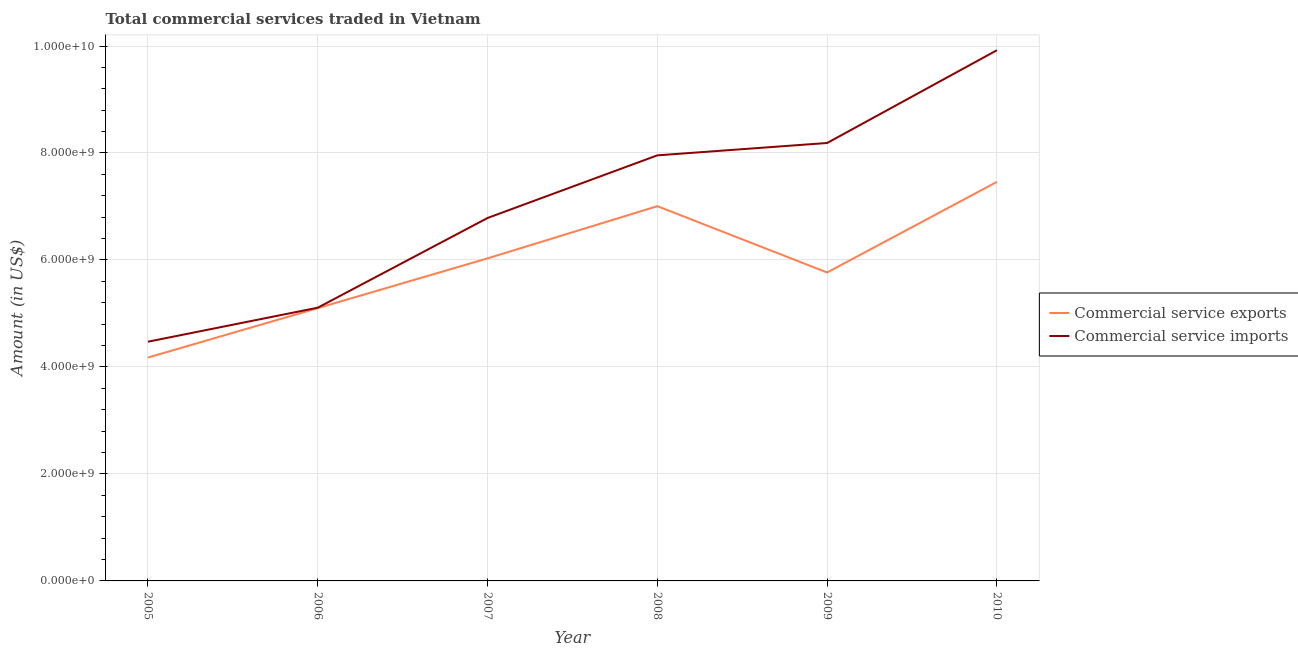How many different coloured lines are there?
Ensure brevity in your answer.  2. What is the amount of commercial service exports in 2009?
Give a very brief answer. 5.77e+09. Across all years, what is the maximum amount of commercial service imports?
Keep it short and to the point. 9.92e+09. Across all years, what is the minimum amount of commercial service exports?
Offer a very short reply. 4.18e+09. What is the total amount of commercial service imports in the graph?
Offer a very short reply. 4.24e+1. What is the difference between the amount of commercial service imports in 2008 and that in 2010?
Your response must be concise. -1.96e+09. What is the difference between the amount of commercial service imports in 2010 and the amount of commercial service exports in 2009?
Ensure brevity in your answer.  4.16e+09. What is the average amount of commercial service imports per year?
Your response must be concise. 7.07e+09. In the year 2009, what is the difference between the amount of commercial service imports and amount of commercial service exports?
Your response must be concise. 2.42e+09. In how many years, is the amount of commercial service exports greater than 8000000000 US$?
Your response must be concise. 0. What is the ratio of the amount of commercial service imports in 2005 to that in 2007?
Your answer should be compact. 0.66. What is the difference between the highest and the second highest amount of commercial service imports?
Keep it short and to the point. 1.73e+09. What is the difference between the highest and the lowest amount of commercial service imports?
Offer a terse response. 5.45e+09. In how many years, is the amount of commercial service imports greater than the average amount of commercial service imports taken over all years?
Your response must be concise. 3. Does the amount of commercial service exports monotonically increase over the years?
Ensure brevity in your answer.  No. How many years are there in the graph?
Your response must be concise. 6. Does the graph contain any zero values?
Your response must be concise. No. Where does the legend appear in the graph?
Provide a short and direct response. Center right. How many legend labels are there?
Give a very brief answer. 2. How are the legend labels stacked?
Offer a very short reply. Vertical. What is the title of the graph?
Offer a very short reply. Total commercial services traded in Vietnam. What is the label or title of the X-axis?
Make the answer very short. Year. What is the Amount (in US$) in Commercial service exports in 2005?
Keep it short and to the point. 4.18e+09. What is the Amount (in US$) in Commercial service imports in 2005?
Offer a very short reply. 4.47e+09. What is the Amount (in US$) of Commercial service exports in 2006?
Offer a very short reply. 5.10e+09. What is the Amount (in US$) in Commercial service imports in 2006?
Make the answer very short. 5.11e+09. What is the Amount (in US$) of Commercial service exports in 2007?
Ensure brevity in your answer.  6.03e+09. What is the Amount (in US$) in Commercial service imports in 2007?
Offer a terse response. 6.78e+09. What is the Amount (in US$) in Commercial service exports in 2008?
Offer a very short reply. 7.01e+09. What is the Amount (in US$) of Commercial service imports in 2008?
Your response must be concise. 7.96e+09. What is the Amount (in US$) of Commercial service exports in 2009?
Provide a short and direct response. 5.77e+09. What is the Amount (in US$) in Commercial service imports in 2009?
Your response must be concise. 8.19e+09. What is the Amount (in US$) in Commercial service exports in 2010?
Your response must be concise. 7.46e+09. What is the Amount (in US$) in Commercial service imports in 2010?
Offer a very short reply. 9.92e+09. Across all years, what is the maximum Amount (in US$) of Commercial service exports?
Offer a very short reply. 7.46e+09. Across all years, what is the maximum Amount (in US$) in Commercial service imports?
Provide a succinct answer. 9.92e+09. Across all years, what is the minimum Amount (in US$) in Commercial service exports?
Offer a terse response. 4.18e+09. Across all years, what is the minimum Amount (in US$) of Commercial service imports?
Provide a short and direct response. 4.47e+09. What is the total Amount (in US$) in Commercial service exports in the graph?
Make the answer very short. 3.55e+1. What is the total Amount (in US$) of Commercial service imports in the graph?
Offer a very short reply. 4.24e+1. What is the difference between the Amount (in US$) in Commercial service exports in 2005 and that in 2006?
Keep it short and to the point. -9.24e+08. What is the difference between the Amount (in US$) of Commercial service imports in 2005 and that in 2006?
Provide a short and direct response. -6.36e+08. What is the difference between the Amount (in US$) in Commercial service exports in 2005 and that in 2007?
Your answer should be very brief. -1.85e+09. What is the difference between the Amount (in US$) of Commercial service imports in 2005 and that in 2007?
Offer a terse response. -2.31e+09. What is the difference between the Amount (in US$) in Commercial service exports in 2005 and that in 2008?
Offer a terse response. -2.83e+09. What is the difference between the Amount (in US$) of Commercial service imports in 2005 and that in 2008?
Offer a terse response. -3.48e+09. What is the difference between the Amount (in US$) in Commercial service exports in 2005 and that in 2009?
Provide a short and direct response. -1.59e+09. What is the difference between the Amount (in US$) in Commercial service imports in 2005 and that in 2009?
Offer a very short reply. -3.72e+09. What is the difference between the Amount (in US$) of Commercial service exports in 2005 and that in 2010?
Keep it short and to the point. -3.28e+09. What is the difference between the Amount (in US$) in Commercial service imports in 2005 and that in 2010?
Provide a succinct answer. -5.45e+09. What is the difference between the Amount (in US$) in Commercial service exports in 2006 and that in 2007?
Make the answer very short. -9.30e+08. What is the difference between the Amount (in US$) of Commercial service imports in 2006 and that in 2007?
Offer a very short reply. -1.68e+09. What is the difference between the Amount (in US$) in Commercial service exports in 2006 and that in 2008?
Make the answer very short. -1.91e+09. What is the difference between the Amount (in US$) in Commercial service imports in 2006 and that in 2008?
Keep it short and to the point. -2.85e+09. What is the difference between the Amount (in US$) in Commercial service exports in 2006 and that in 2009?
Provide a short and direct response. -6.66e+08. What is the difference between the Amount (in US$) in Commercial service imports in 2006 and that in 2009?
Your answer should be compact. -3.08e+09. What is the difference between the Amount (in US$) in Commercial service exports in 2006 and that in 2010?
Ensure brevity in your answer.  -2.36e+09. What is the difference between the Amount (in US$) in Commercial service imports in 2006 and that in 2010?
Your answer should be very brief. -4.81e+09. What is the difference between the Amount (in US$) in Commercial service exports in 2007 and that in 2008?
Give a very brief answer. -9.76e+08. What is the difference between the Amount (in US$) of Commercial service imports in 2007 and that in 2008?
Your answer should be compact. -1.17e+09. What is the difference between the Amount (in US$) of Commercial service exports in 2007 and that in 2009?
Your answer should be compact. 2.64e+08. What is the difference between the Amount (in US$) in Commercial service imports in 2007 and that in 2009?
Provide a succinct answer. -1.40e+09. What is the difference between the Amount (in US$) of Commercial service exports in 2007 and that in 2010?
Give a very brief answer. -1.43e+09. What is the difference between the Amount (in US$) of Commercial service imports in 2007 and that in 2010?
Provide a succinct answer. -3.14e+09. What is the difference between the Amount (in US$) of Commercial service exports in 2008 and that in 2009?
Offer a very short reply. 1.24e+09. What is the difference between the Amount (in US$) of Commercial service imports in 2008 and that in 2009?
Provide a short and direct response. -2.31e+08. What is the difference between the Amount (in US$) in Commercial service exports in 2008 and that in 2010?
Offer a terse response. -4.54e+08. What is the difference between the Amount (in US$) in Commercial service imports in 2008 and that in 2010?
Your answer should be very brief. -1.96e+09. What is the difference between the Amount (in US$) of Commercial service exports in 2009 and that in 2010?
Offer a very short reply. -1.69e+09. What is the difference between the Amount (in US$) in Commercial service imports in 2009 and that in 2010?
Make the answer very short. -1.73e+09. What is the difference between the Amount (in US$) of Commercial service exports in 2005 and the Amount (in US$) of Commercial service imports in 2006?
Give a very brief answer. -9.32e+08. What is the difference between the Amount (in US$) of Commercial service exports in 2005 and the Amount (in US$) of Commercial service imports in 2007?
Provide a short and direct response. -2.61e+09. What is the difference between the Amount (in US$) in Commercial service exports in 2005 and the Amount (in US$) in Commercial service imports in 2008?
Offer a very short reply. -3.78e+09. What is the difference between the Amount (in US$) of Commercial service exports in 2005 and the Amount (in US$) of Commercial service imports in 2009?
Your answer should be compact. -4.01e+09. What is the difference between the Amount (in US$) in Commercial service exports in 2005 and the Amount (in US$) in Commercial service imports in 2010?
Provide a succinct answer. -5.74e+09. What is the difference between the Amount (in US$) of Commercial service exports in 2006 and the Amount (in US$) of Commercial service imports in 2007?
Provide a short and direct response. -1.68e+09. What is the difference between the Amount (in US$) of Commercial service exports in 2006 and the Amount (in US$) of Commercial service imports in 2008?
Provide a short and direct response. -2.86e+09. What is the difference between the Amount (in US$) in Commercial service exports in 2006 and the Amount (in US$) in Commercial service imports in 2009?
Your answer should be very brief. -3.09e+09. What is the difference between the Amount (in US$) in Commercial service exports in 2006 and the Amount (in US$) in Commercial service imports in 2010?
Provide a succinct answer. -4.82e+09. What is the difference between the Amount (in US$) in Commercial service exports in 2007 and the Amount (in US$) in Commercial service imports in 2008?
Offer a terse response. -1.93e+09. What is the difference between the Amount (in US$) of Commercial service exports in 2007 and the Amount (in US$) of Commercial service imports in 2009?
Your answer should be very brief. -2.16e+09. What is the difference between the Amount (in US$) of Commercial service exports in 2007 and the Amount (in US$) of Commercial service imports in 2010?
Ensure brevity in your answer.  -3.89e+09. What is the difference between the Amount (in US$) in Commercial service exports in 2008 and the Amount (in US$) in Commercial service imports in 2009?
Ensure brevity in your answer.  -1.18e+09. What is the difference between the Amount (in US$) of Commercial service exports in 2008 and the Amount (in US$) of Commercial service imports in 2010?
Your answer should be compact. -2.92e+09. What is the difference between the Amount (in US$) of Commercial service exports in 2009 and the Amount (in US$) of Commercial service imports in 2010?
Keep it short and to the point. -4.16e+09. What is the average Amount (in US$) of Commercial service exports per year?
Your response must be concise. 5.92e+09. What is the average Amount (in US$) in Commercial service imports per year?
Give a very brief answer. 7.07e+09. In the year 2005, what is the difference between the Amount (in US$) in Commercial service exports and Amount (in US$) in Commercial service imports?
Provide a succinct answer. -2.96e+08. In the year 2006, what is the difference between the Amount (in US$) of Commercial service exports and Amount (in US$) of Commercial service imports?
Make the answer very short. -8.18e+06. In the year 2007, what is the difference between the Amount (in US$) of Commercial service exports and Amount (in US$) of Commercial service imports?
Make the answer very short. -7.55e+08. In the year 2008, what is the difference between the Amount (in US$) in Commercial service exports and Amount (in US$) in Commercial service imports?
Ensure brevity in your answer.  -9.50e+08. In the year 2009, what is the difference between the Amount (in US$) in Commercial service exports and Amount (in US$) in Commercial service imports?
Provide a succinct answer. -2.42e+09. In the year 2010, what is the difference between the Amount (in US$) in Commercial service exports and Amount (in US$) in Commercial service imports?
Ensure brevity in your answer.  -2.46e+09. What is the ratio of the Amount (in US$) in Commercial service exports in 2005 to that in 2006?
Your answer should be very brief. 0.82. What is the ratio of the Amount (in US$) in Commercial service imports in 2005 to that in 2006?
Offer a very short reply. 0.88. What is the ratio of the Amount (in US$) of Commercial service exports in 2005 to that in 2007?
Provide a short and direct response. 0.69. What is the ratio of the Amount (in US$) of Commercial service imports in 2005 to that in 2007?
Provide a short and direct response. 0.66. What is the ratio of the Amount (in US$) in Commercial service exports in 2005 to that in 2008?
Provide a short and direct response. 0.6. What is the ratio of the Amount (in US$) of Commercial service imports in 2005 to that in 2008?
Keep it short and to the point. 0.56. What is the ratio of the Amount (in US$) in Commercial service exports in 2005 to that in 2009?
Ensure brevity in your answer.  0.72. What is the ratio of the Amount (in US$) of Commercial service imports in 2005 to that in 2009?
Keep it short and to the point. 0.55. What is the ratio of the Amount (in US$) in Commercial service exports in 2005 to that in 2010?
Offer a terse response. 0.56. What is the ratio of the Amount (in US$) in Commercial service imports in 2005 to that in 2010?
Your answer should be compact. 0.45. What is the ratio of the Amount (in US$) in Commercial service exports in 2006 to that in 2007?
Offer a very short reply. 0.85. What is the ratio of the Amount (in US$) of Commercial service imports in 2006 to that in 2007?
Your answer should be very brief. 0.75. What is the ratio of the Amount (in US$) of Commercial service exports in 2006 to that in 2008?
Make the answer very short. 0.73. What is the ratio of the Amount (in US$) of Commercial service imports in 2006 to that in 2008?
Keep it short and to the point. 0.64. What is the ratio of the Amount (in US$) of Commercial service exports in 2006 to that in 2009?
Your answer should be very brief. 0.88. What is the ratio of the Amount (in US$) of Commercial service imports in 2006 to that in 2009?
Your answer should be very brief. 0.62. What is the ratio of the Amount (in US$) of Commercial service exports in 2006 to that in 2010?
Make the answer very short. 0.68. What is the ratio of the Amount (in US$) of Commercial service imports in 2006 to that in 2010?
Make the answer very short. 0.51. What is the ratio of the Amount (in US$) of Commercial service exports in 2007 to that in 2008?
Keep it short and to the point. 0.86. What is the ratio of the Amount (in US$) in Commercial service imports in 2007 to that in 2008?
Offer a terse response. 0.85. What is the ratio of the Amount (in US$) of Commercial service exports in 2007 to that in 2009?
Your answer should be compact. 1.05. What is the ratio of the Amount (in US$) in Commercial service imports in 2007 to that in 2009?
Give a very brief answer. 0.83. What is the ratio of the Amount (in US$) in Commercial service exports in 2007 to that in 2010?
Your answer should be compact. 0.81. What is the ratio of the Amount (in US$) of Commercial service imports in 2007 to that in 2010?
Make the answer very short. 0.68. What is the ratio of the Amount (in US$) of Commercial service exports in 2008 to that in 2009?
Offer a terse response. 1.22. What is the ratio of the Amount (in US$) of Commercial service imports in 2008 to that in 2009?
Give a very brief answer. 0.97. What is the ratio of the Amount (in US$) in Commercial service exports in 2008 to that in 2010?
Your response must be concise. 0.94. What is the ratio of the Amount (in US$) in Commercial service imports in 2008 to that in 2010?
Your answer should be very brief. 0.8. What is the ratio of the Amount (in US$) of Commercial service exports in 2009 to that in 2010?
Your response must be concise. 0.77. What is the ratio of the Amount (in US$) in Commercial service imports in 2009 to that in 2010?
Give a very brief answer. 0.83. What is the difference between the highest and the second highest Amount (in US$) in Commercial service exports?
Provide a short and direct response. 4.54e+08. What is the difference between the highest and the second highest Amount (in US$) of Commercial service imports?
Offer a terse response. 1.73e+09. What is the difference between the highest and the lowest Amount (in US$) in Commercial service exports?
Provide a short and direct response. 3.28e+09. What is the difference between the highest and the lowest Amount (in US$) in Commercial service imports?
Keep it short and to the point. 5.45e+09. 